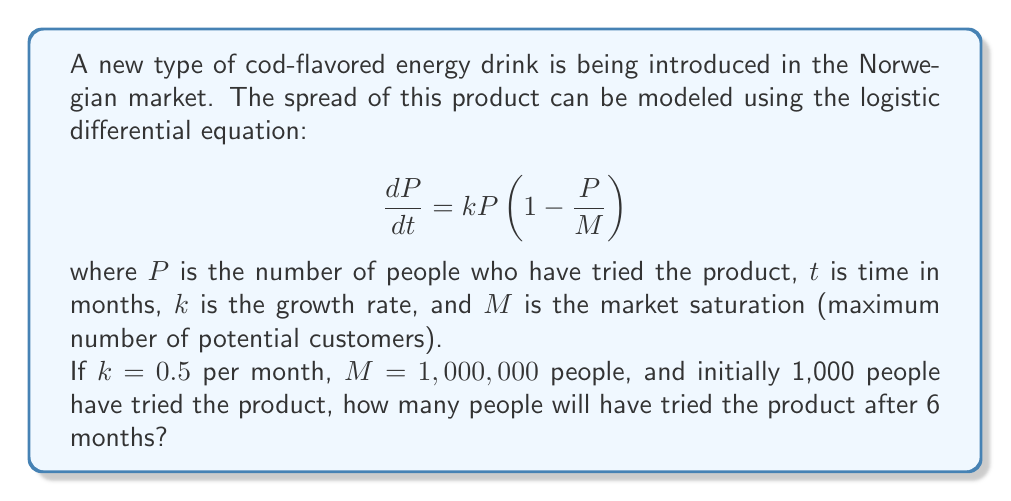Give your solution to this math problem. To solve this problem, we need to use the solution to the logistic differential equation:

$$P(t) = \frac{M}{1 + (\frac{M}{P_0} - 1)e^{-kt}}$$

where $P_0$ is the initial number of people who have tried the product.

Given:
- $k = 0.5$ per month
- $M = 1,000,000$ people
- $P_0 = 1,000$ people
- $t = 6$ months

Let's substitute these values into the equation:

$$P(6) = \frac{1,000,000}{1 + (\frac{1,000,000}{1,000} - 1)e^{-0.5 \cdot 6}}$$

$$= \frac{1,000,000}{1 + (999)e^{-3}}$$

Now, let's calculate this step by step:

1. Calculate $e^{-3}$:
   $e^{-3} \approx 0.0498$

2. Multiply 999 by 0.0498:
   $999 \cdot 0.0498 \approx 49.75$

3. Add 1 to the result:
   $1 + 49.75 = 50.75$

4. Divide 1,000,000 by 50.75:
   $\frac{1,000,000}{50.75} \approx 19,704$

Therefore, after 6 months, approximately 19,704 people will have tried the cod-flavored energy drink.
Answer: 19,704 people 